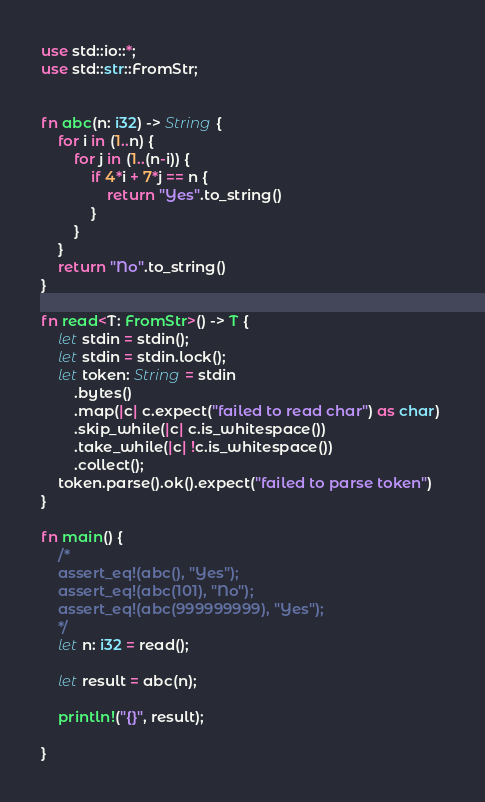<code> <loc_0><loc_0><loc_500><loc_500><_Rust_>use std::io::*;
use std::str::FromStr;


fn abc(n: i32) -> String {
    for i in (1..n) {
        for j in (1..(n-i)) {
            if 4*i + 7*j == n {
                return "Yes".to_string()
            }
        }
    }
    return "No".to_string()
}

fn read<T: FromStr>() -> T {
    let stdin = stdin();
    let stdin = stdin.lock();
    let token: String = stdin
        .bytes()
        .map(|c| c.expect("failed to read char") as char) 
        .skip_while(|c| c.is_whitespace())
        .take_while(|c| !c.is_whitespace())
        .collect();
    token.parse().ok().expect("failed to parse token")
}

fn main() {
    /*
    assert_eq!(abc(), "Yes");
    assert_eq!(abc(101), "No");
    assert_eq!(abc(999999999), "Yes");
    */
    let n: i32 = read();

    let result = abc(n);
    
    println!("{}", result);
    
}

</code> 